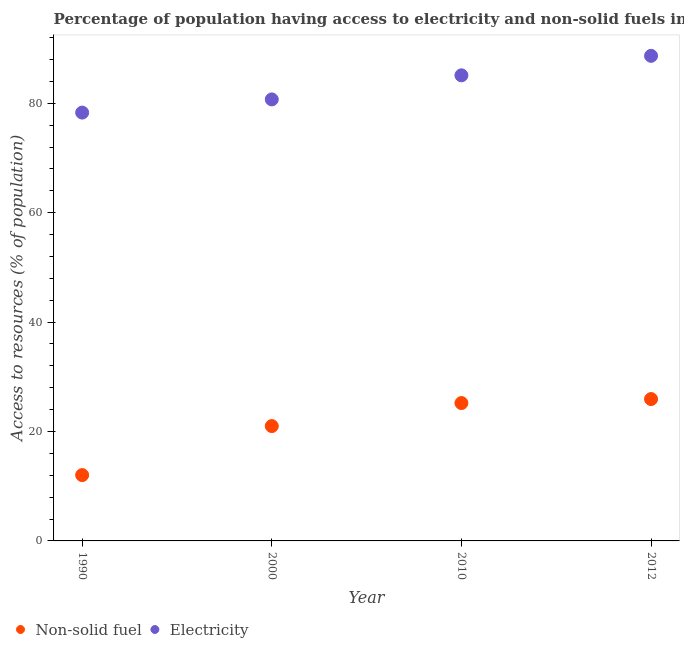Is the number of dotlines equal to the number of legend labels?
Provide a succinct answer. Yes. What is the percentage of population having access to electricity in 2000?
Keep it short and to the point. 80.7. Across all years, what is the maximum percentage of population having access to electricity?
Offer a very short reply. 88.66. Across all years, what is the minimum percentage of population having access to non-solid fuel?
Give a very brief answer. 12.03. What is the total percentage of population having access to non-solid fuel in the graph?
Your response must be concise. 84.15. What is the difference between the percentage of population having access to non-solid fuel in 1990 and that in 2000?
Keep it short and to the point. -8.96. What is the difference between the percentage of population having access to electricity in 2010 and the percentage of population having access to non-solid fuel in 2000?
Offer a very short reply. 64.11. What is the average percentage of population having access to electricity per year?
Give a very brief answer. 83.19. In the year 2012, what is the difference between the percentage of population having access to non-solid fuel and percentage of population having access to electricity?
Ensure brevity in your answer.  -62.73. What is the ratio of the percentage of population having access to non-solid fuel in 2000 to that in 2010?
Your response must be concise. 0.83. Is the difference between the percentage of population having access to electricity in 2010 and 2012 greater than the difference between the percentage of population having access to non-solid fuel in 2010 and 2012?
Provide a succinct answer. No. What is the difference between the highest and the second highest percentage of population having access to non-solid fuel?
Your answer should be very brief. 0.73. What is the difference between the highest and the lowest percentage of population having access to non-solid fuel?
Offer a terse response. 13.9. In how many years, is the percentage of population having access to non-solid fuel greater than the average percentage of population having access to non-solid fuel taken over all years?
Offer a terse response. 2. Is the sum of the percentage of population having access to electricity in 1990 and 2010 greater than the maximum percentage of population having access to non-solid fuel across all years?
Ensure brevity in your answer.  Yes. Does the percentage of population having access to non-solid fuel monotonically increase over the years?
Keep it short and to the point. Yes. Is the percentage of population having access to non-solid fuel strictly greater than the percentage of population having access to electricity over the years?
Your answer should be very brief. No. How many dotlines are there?
Offer a very short reply. 2. How many years are there in the graph?
Keep it short and to the point. 4. What is the difference between two consecutive major ticks on the Y-axis?
Keep it short and to the point. 20. Does the graph contain grids?
Your answer should be compact. No. Where does the legend appear in the graph?
Offer a very short reply. Bottom left. How many legend labels are there?
Provide a short and direct response. 2. How are the legend labels stacked?
Offer a very short reply. Horizontal. What is the title of the graph?
Offer a terse response. Percentage of population having access to electricity and non-solid fuels in Sri Lanka. What is the label or title of the X-axis?
Provide a succinct answer. Year. What is the label or title of the Y-axis?
Make the answer very short. Access to resources (% of population). What is the Access to resources (% of population) in Non-solid fuel in 1990?
Your answer should be compact. 12.03. What is the Access to resources (% of population) in Electricity in 1990?
Make the answer very short. 78.29. What is the Access to resources (% of population) of Non-solid fuel in 2000?
Keep it short and to the point. 20.99. What is the Access to resources (% of population) of Electricity in 2000?
Your answer should be very brief. 80.7. What is the Access to resources (% of population) of Non-solid fuel in 2010?
Provide a succinct answer. 25.2. What is the Access to resources (% of population) in Electricity in 2010?
Your response must be concise. 85.1. What is the Access to resources (% of population) of Non-solid fuel in 2012?
Offer a very short reply. 25.93. What is the Access to resources (% of population) of Electricity in 2012?
Make the answer very short. 88.66. Across all years, what is the maximum Access to resources (% of population) of Non-solid fuel?
Ensure brevity in your answer.  25.93. Across all years, what is the maximum Access to resources (% of population) in Electricity?
Offer a very short reply. 88.66. Across all years, what is the minimum Access to resources (% of population) of Non-solid fuel?
Provide a short and direct response. 12.03. Across all years, what is the minimum Access to resources (% of population) of Electricity?
Provide a short and direct response. 78.29. What is the total Access to resources (% of population) in Non-solid fuel in the graph?
Your response must be concise. 84.15. What is the total Access to resources (% of population) of Electricity in the graph?
Your response must be concise. 332.75. What is the difference between the Access to resources (% of population) of Non-solid fuel in 1990 and that in 2000?
Ensure brevity in your answer.  -8.96. What is the difference between the Access to resources (% of population) of Electricity in 1990 and that in 2000?
Your response must be concise. -2.41. What is the difference between the Access to resources (% of population) of Non-solid fuel in 1990 and that in 2010?
Provide a short and direct response. -13.17. What is the difference between the Access to resources (% of population) in Electricity in 1990 and that in 2010?
Make the answer very short. -6.81. What is the difference between the Access to resources (% of population) in Non-solid fuel in 1990 and that in 2012?
Offer a terse response. -13.9. What is the difference between the Access to resources (% of population) of Electricity in 1990 and that in 2012?
Ensure brevity in your answer.  -10.37. What is the difference between the Access to resources (% of population) in Non-solid fuel in 2000 and that in 2010?
Provide a succinct answer. -4.21. What is the difference between the Access to resources (% of population) of Electricity in 2000 and that in 2010?
Offer a terse response. -4.4. What is the difference between the Access to resources (% of population) of Non-solid fuel in 2000 and that in 2012?
Ensure brevity in your answer.  -4.94. What is the difference between the Access to resources (% of population) in Electricity in 2000 and that in 2012?
Ensure brevity in your answer.  -7.96. What is the difference between the Access to resources (% of population) in Non-solid fuel in 2010 and that in 2012?
Offer a terse response. -0.73. What is the difference between the Access to resources (% of population) in Electricity in 2010 and that in 2012?
Offer a very short reply. -3.56. What is the difference between the Access to resources (% of population) in Non-solid fuel in 1990 and the Access to resources (% of population) in Electricity in 2000?
Your answer should be very brief. -68.67. What is the difference between the Access to resources (% of population) in Non-solid fuel in 1990 and the Access to resources (% of population) in Electricity in 2010?
Offer a very short reply. -73.07. What is the difference between the Access to resources (% of population) in Non-solid fuel in 1990 and the Access to resources (% of population) in Electricity in 2012?
Provide a short and direct response. -76.63. What is the difference between the Access to resources (% of population) in Non-solid fuel in 2000 and the Access to resources (% of population) in Electricity in 2010?
Keep it short and to the point. -64.11. What is the difference between the Access to resources (% of population) of Non-solid fuel in 2000 and the Access to resources (% of population) of Electricity in 2012?
Your response must be concise. -67.67. What is the difference between the Access to resources (% of population) in Non-solid fuel in 2010 and the Access to resources (% of population) in Electricity in 2012?
Your response must be concise. -63.46. What is the average Access to resources (% of population) in Non-solid fuel per year?
Ensure brevity in your answer.  21.04. What is the average Access to resources (% of population) of Electricity per year?
Give a very brief answer. 83.19. In the year 1990, what is the difference between the Access to resources (% of population) of Non-solid fuel and Access to resources (% of population) of Electricity?
Provide a short and direct response. -66.26. In the year 2000, what is the difference between the Access to resources (% of population) in Non-solid fuel and Access to resources (% of population) in Electricity?
Ensure brevity in your answer.  -59.71. In the year 2010, what is the difference between the Access to resources (% of population) in Non-solid fuel and Access to resources (% of population) in Electricity?
Your answer should be compact. -59.9. In the year 2012, what is the difference between the Access to resources (% of population) in Non-solid fuel and Access to resources (% of population) in Electricity?
Offer a very short reply. -62.73. What is the ratio of the Access to resources (% of population) in Non-solid fuel in 1990 to that in 2000?
Give a very brief answer. 0.57. What is the ratio of the Access to resources (% of population) of Electricity in 1990 to that in 2000?
Offer a very short reply. 0.97. What is the ratio of the Access to resources (% of population) in Non-solid fuel in 1990 to that in 2010?
Offer a terse response. 0.48. What is the ratio of the Access to resources (% of population) of Electricity in 1990 to that in 2010?
Provide a succinct answer. 0.92. What is the ratio of the Access to resources (% of population) of Non-solid fuel in 1990 to that in 2012?
Your answer should be compact. 0.46. What is the ratio of the Access to resources (% of population) of Electricity in 1990 to that in 2012?
Your response must be concise. 0.88. What is the ratio of the Access to resources (% of population) of Non-solid fuel in 2000 to that in 2010?
Keep it short and to the point. 0.83. What is the ratio of the Access to resources (% of population) of Electricity in 2000 to that in 2010?
Make the answer very short. 0.95. What is the ratio of the Access to resources (% of population) in Non-solid fuel in 2000 to that in 2012?
Give a very brief answer. 0.81. What is the ratio of the Access to resources (% of population) of Electricity in 2000 to that in 2012?
Provide a short and direct response. 0.91. What is the ratio of the Access to resources (% of population) of Non-solid fuel in 2010 to that in 2012?
Offer a very short reply. 0.97. What is the ratio of the Access to resources (% of population) in Electricity in 2010 to that in 2012?
Keep it short and to the point. 0.96. What is the difference between the highest and the second highest Access to resources (% of population) in Non-solid fuel?
Give a very brief answer. 0.73. What is the difference between the highest and the second highest Access to resources (% of population) in Electricity?
Provide a succinct answer. 3.56. What is the difference between the highest and the lowest Access to resources (% of population) of Non-solid fuel?
Provide a short and direct response. 13.9. What is the difference between the highest and the lowest Access to resources (% of population) in Electricity?
Your response must be concise. 10.37. 